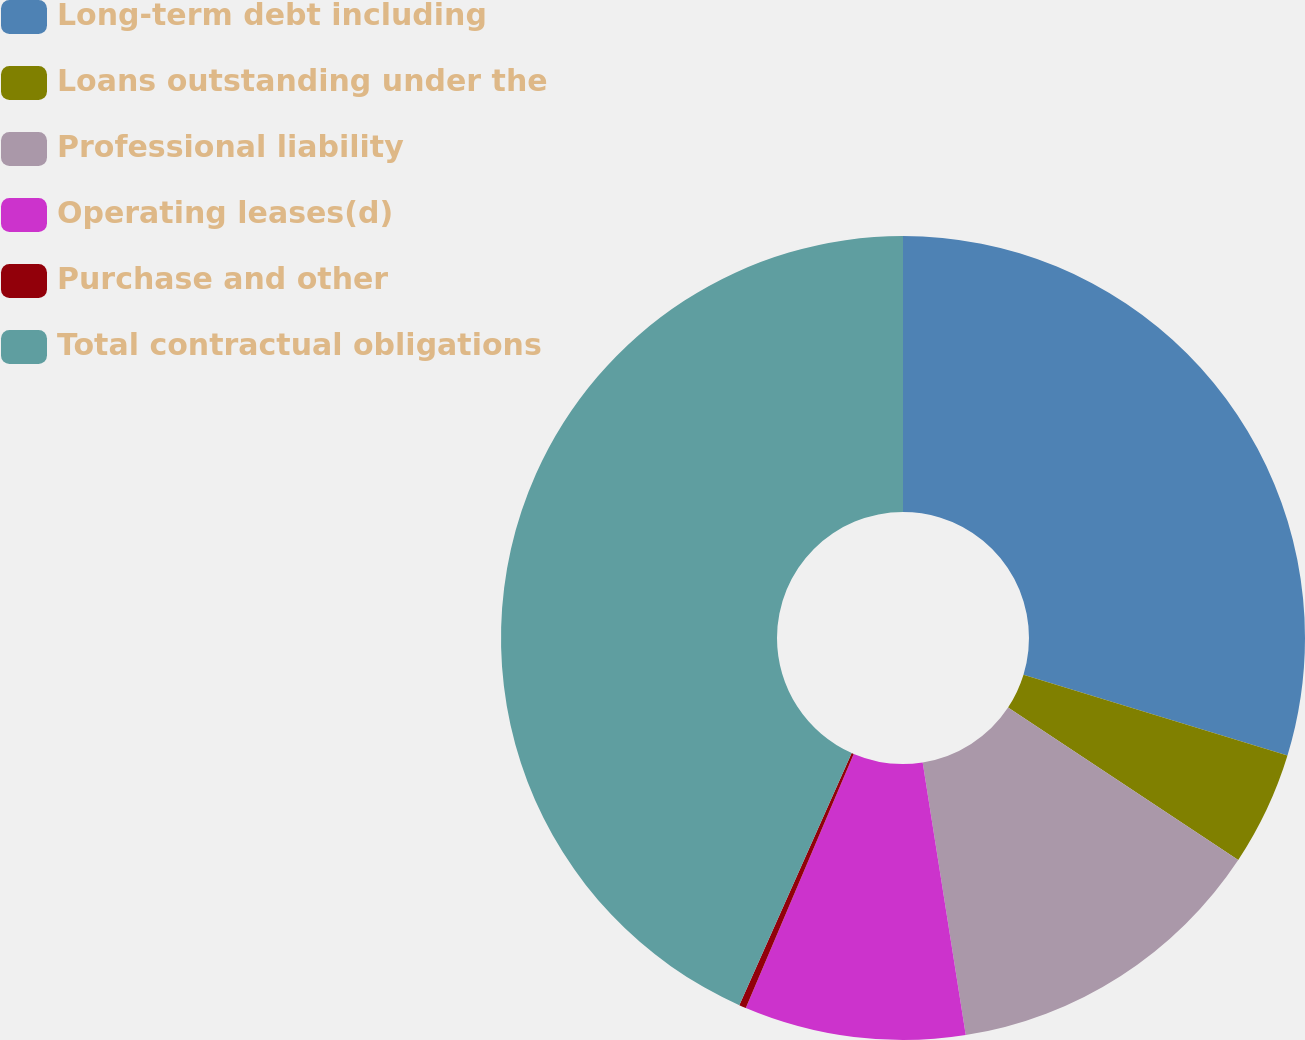Convert chart to OTSL. <chart><loc_0><loc_0><loc_500><loc_500><pie_chart><fcel>Long-term debt including<fcel>Loans outstanding under the<fcel>Professional liability<fcel>Operating leases(d)<fcel>Purchase and other<fcel>Total contractual obligations<nl><fcel>29.72%<fcel>4.59%<fcel>13.2%<fcel>8.89%<fcel>0.28%<fcel>43.33%<nl></chart> 